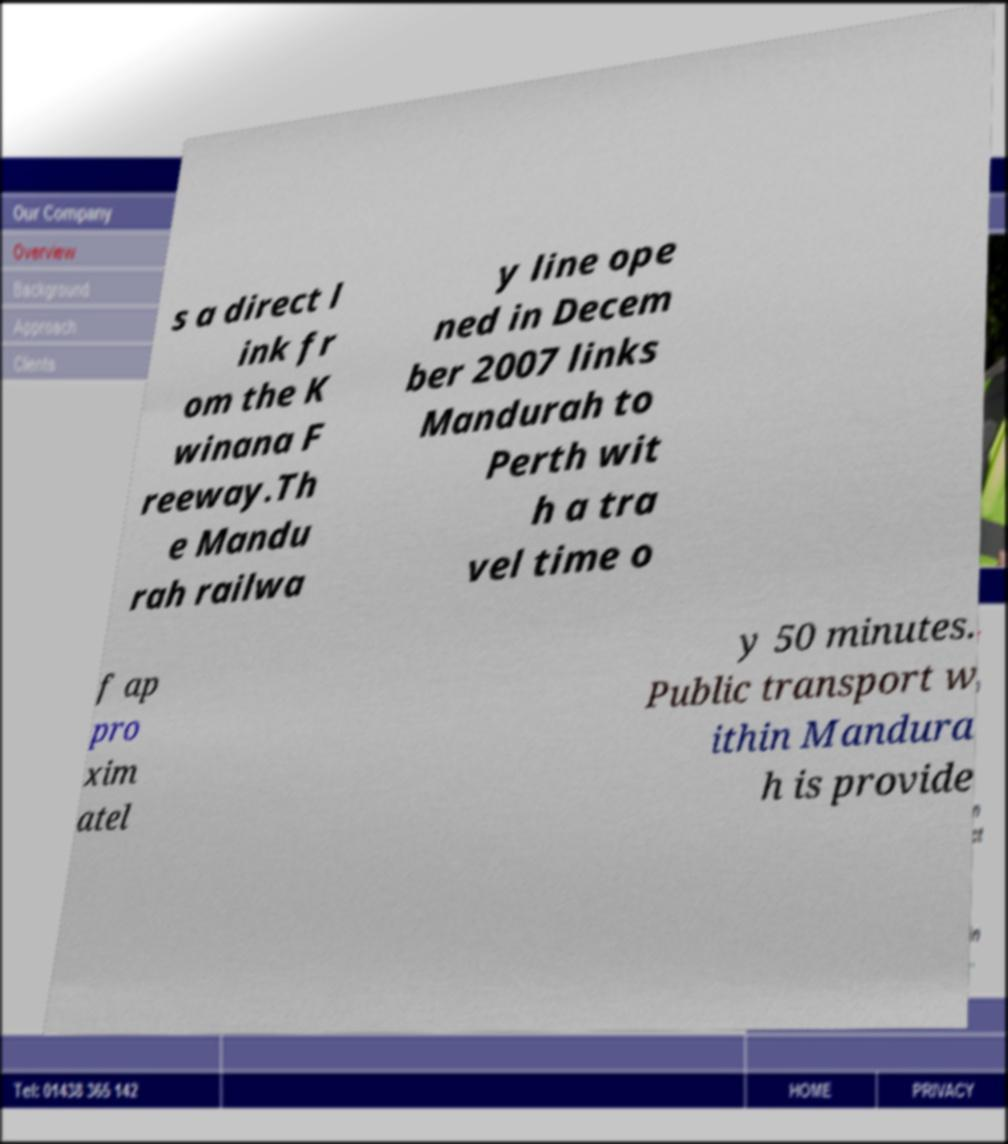What messages or text are displayed in this image? I need them in a readable, typed format. s a direct l ink fr om the K winana F reeway.Th e Mandu rah railwa y line ope ned in Decem ber 2007 links Mandurah to Perth wit h a tra vel time o f ap pro xim atel y 50 minutes. Public transport w ithin Mandura h is provide 